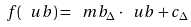Convert formula to latex. <formula><loc_0><loc_0><loc_500><loc_500>f ( \ u b ) = \ m b _ { \Delta } \cdot \ u b + c _ { \Delta }</formula> 